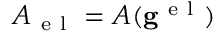<formula> <loc_0><loc_0><loc_500><loc_500>A _ { e l } = A ( g ^ { e l } )</formula> 